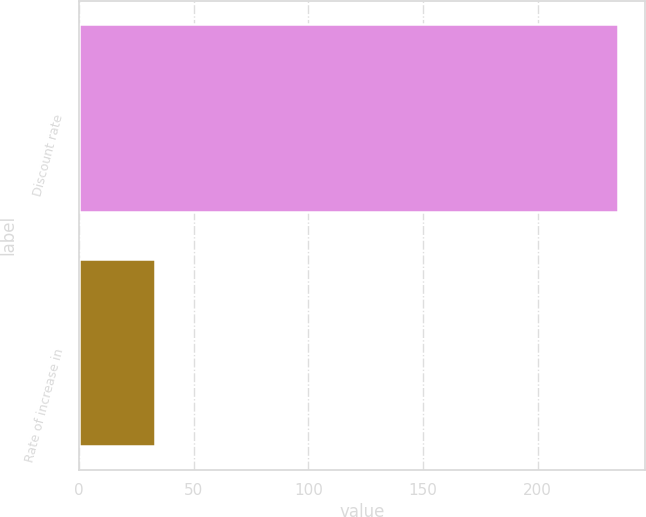Convert chart. <chart><loc_0><loc_0><loc_500><loc_500><bar_chart><fcel>Discount rate<fcel>Rate of increase in<nl><fcel>235<fcel>33<nl></chart> 